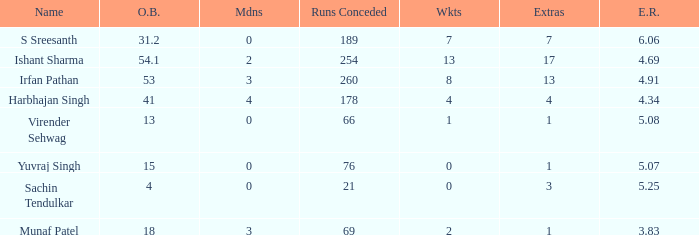Specify the wickets for a 15-over bowling spell. 0.0. 